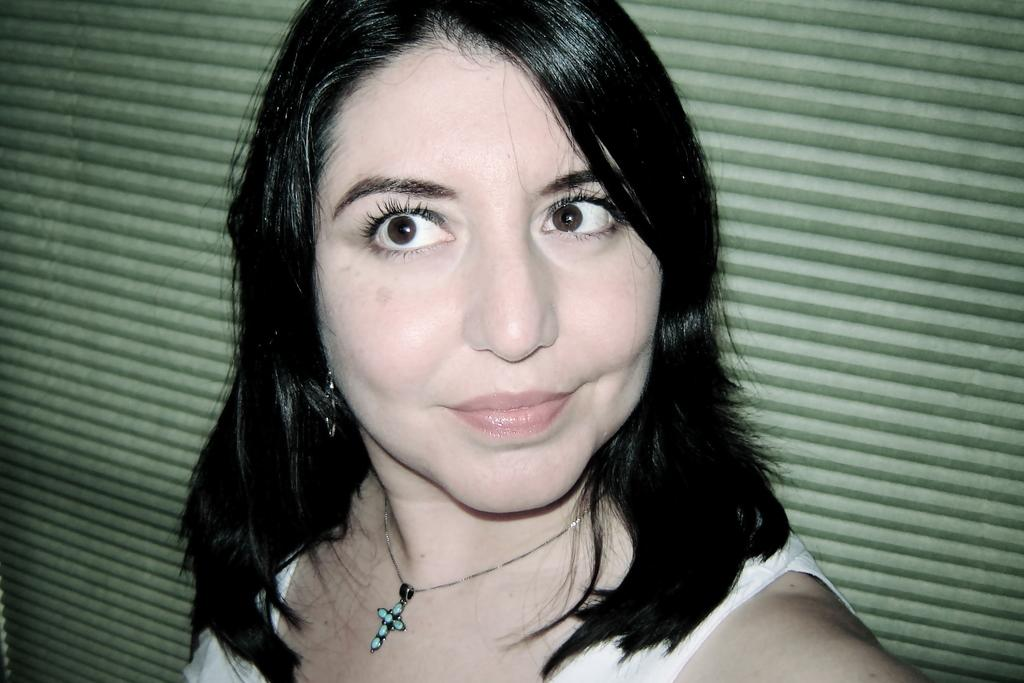Who is the main subject in the image? There is a woman in the image. What is the woman wearing? The woman is wearing a white dress. Are there any accessories visible on the woman? Yes, the woman has a locket around her neck. What can be seen in the background of the image? There is a green-colored shutter in the background of the image. What time does the alarm go off in the image? There is no alarm present in the image. Can you describe the woman's stretching routine in the image? The woman is not stretching in the image; she is simply standing or posing. 